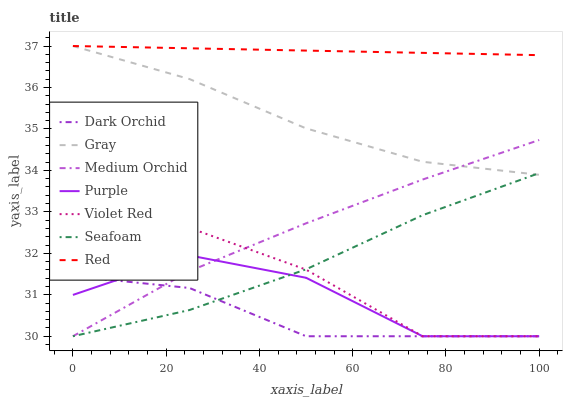Does Dark Orchid have the minimum area under the curve?
Answer yes or no. Yes. Does Red have the maximum area under the curve?
Answer yes or no. Yes. Does Violet Red have the minimum area under the curve?
Answer yes or no. No. Does Violet Red have the maximum area under the curve?
Answer yes or no. No. Is Red the smoothest?
Answer yes or no. Yes. Is Violet Red the roughest?
Answer yes or no. Yes. Is Purple the smoothest?
Answer yes or no. No. Is Purple the roughest?
Answer yes or no. No. Does Violet Red have the lowest value?
Answer yes or no. Yes. Does Red have the lowest value?
Answer yes or no. No. Does Red have the highest value?
Answer yes or no. Yes. Does Violet Red have the highest value?
Answer yes or no. No. Is Dark Orchid less than Red?
Answer yes or no. Yes. Is Red greater than Violet Red?
Answer yes or no. Yes. Does Purple intersect Dark Orchid?
Answer yes or no. Yes. Is Purple less than Dark Orchid?
Answer yes or no. No. Is Purple greater than Dark Orchid?
Answer yes or no. No. Does Dark Orchid intersect Red?
Answer yes or no. No. 